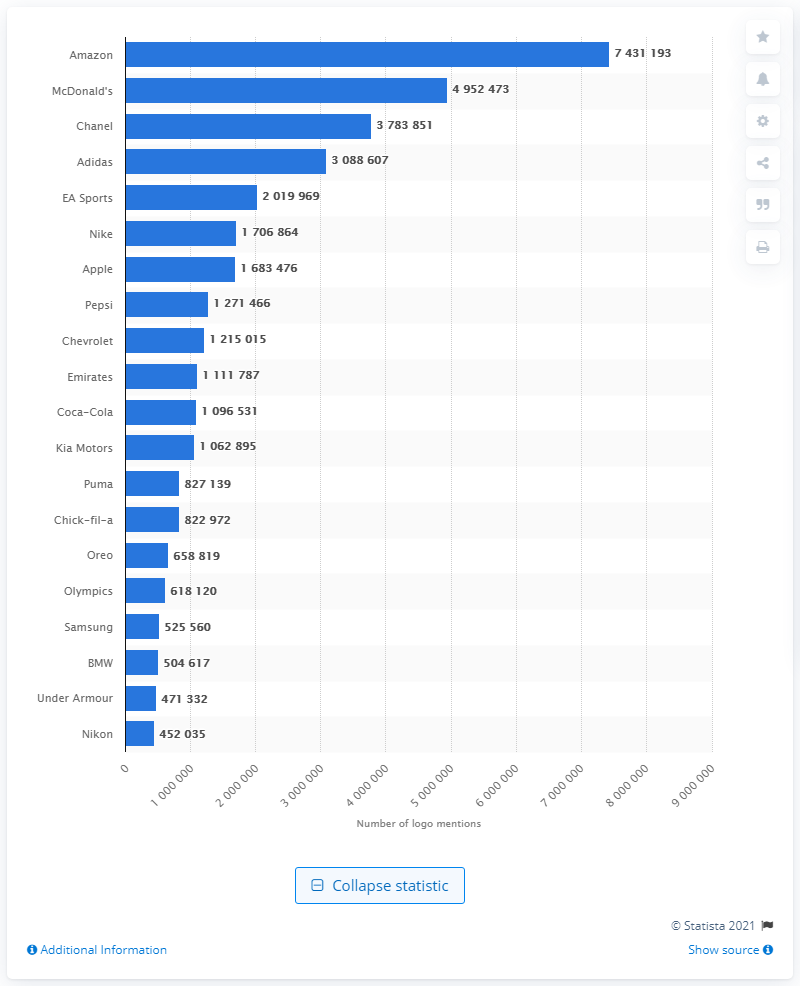Give some essential details in this illustration. Nike was featured on over 1.7 million images between September 2018 and February 2019. 